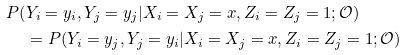<formula> <loc_0><loc_0><loc_500><loc_500>P ( & Y _ { i } = y _ { i } , Y _ { j } = y _ { j } | X _ { i } = X _ { j } = x , Z _ { i } = Z _ { j } = 1 ; \mathcal { O } ) \\ & = P ( Y _ { i } = y _ { j } , Y _ { j } = y _ { i } | X _ { i } = X _ { j } = x , Z _ { i } = Z _ { j } = 1 ; \mathcal { O } )</formula> 